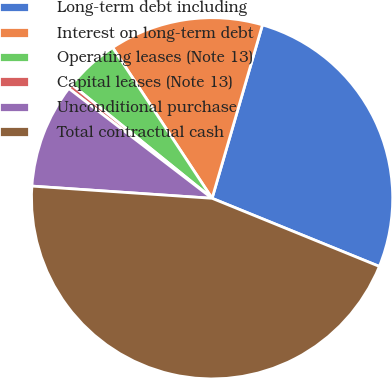<chart> <loc_0><loc_0><loc_500><loc_500><pie_chart><fcel>Long-term debt including<fcel>Interest on long-term debt<fcel>Operating leases (Note 13)<fcel>Capital leases (Note 13)<fcel>Unconditional purchase<fcel>Total contractual cash<nl><fcel>26.66%<fcel>13.78%<fcel>4.88%<fcel>0.43%<fcel>9.33%<fcel>44.92%<nl></chart> 